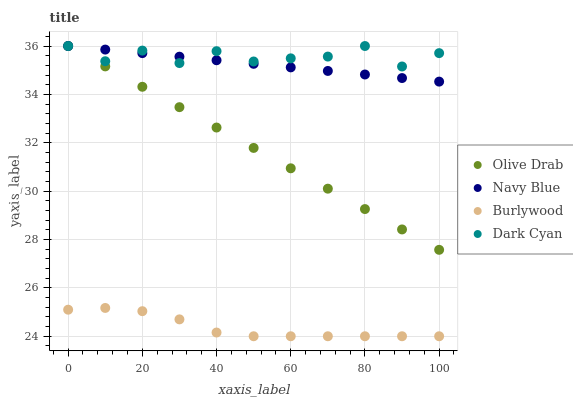Does Burlywood have the minimum area under the curve?
Answer yes or no. Yes. Does Dark Cyan have the maximum area under the curve?
Answer yes or no. Yes. Does Navy Blue have the minimum area under the curve?
Answer yes or no. No. Does Navy Blue have the maximum area under the curve?
Answer yes or no. No. Is Olive Drab the smoothest?
Answer yes or no. Yes. Is Dark Cyan the roughest?
Answer yes or no. Yes. Is Navy Blue the smoothest?
Answer yes or no. No. Is Navy Blue the roughest?
Answer yes or no. No. Does Burlywood have the lowest value?
Answer yes or no. Yes. Does Navy Blue have the lowest value?
Answer yes or no. No. Does Olive Drab have the highest value?
Answer yes or no. Yes. Is Burlywood less than Dark Cyan?
Answer yes or no. Yes. Is Olive Drab greater than Burlywood?
Answer yes or no. Yes. Does Olive Drab intersect Dark Cyan?
Answer yes or no. Yes. Is Olive Drab less than Dark Cyan?
Answer yes or no. No. Is Olive Drab greater than Dark Cyan?
Answer yes or no. No. Does Burlywood intersect Dark Cyan?
Answer yes or no. No. 